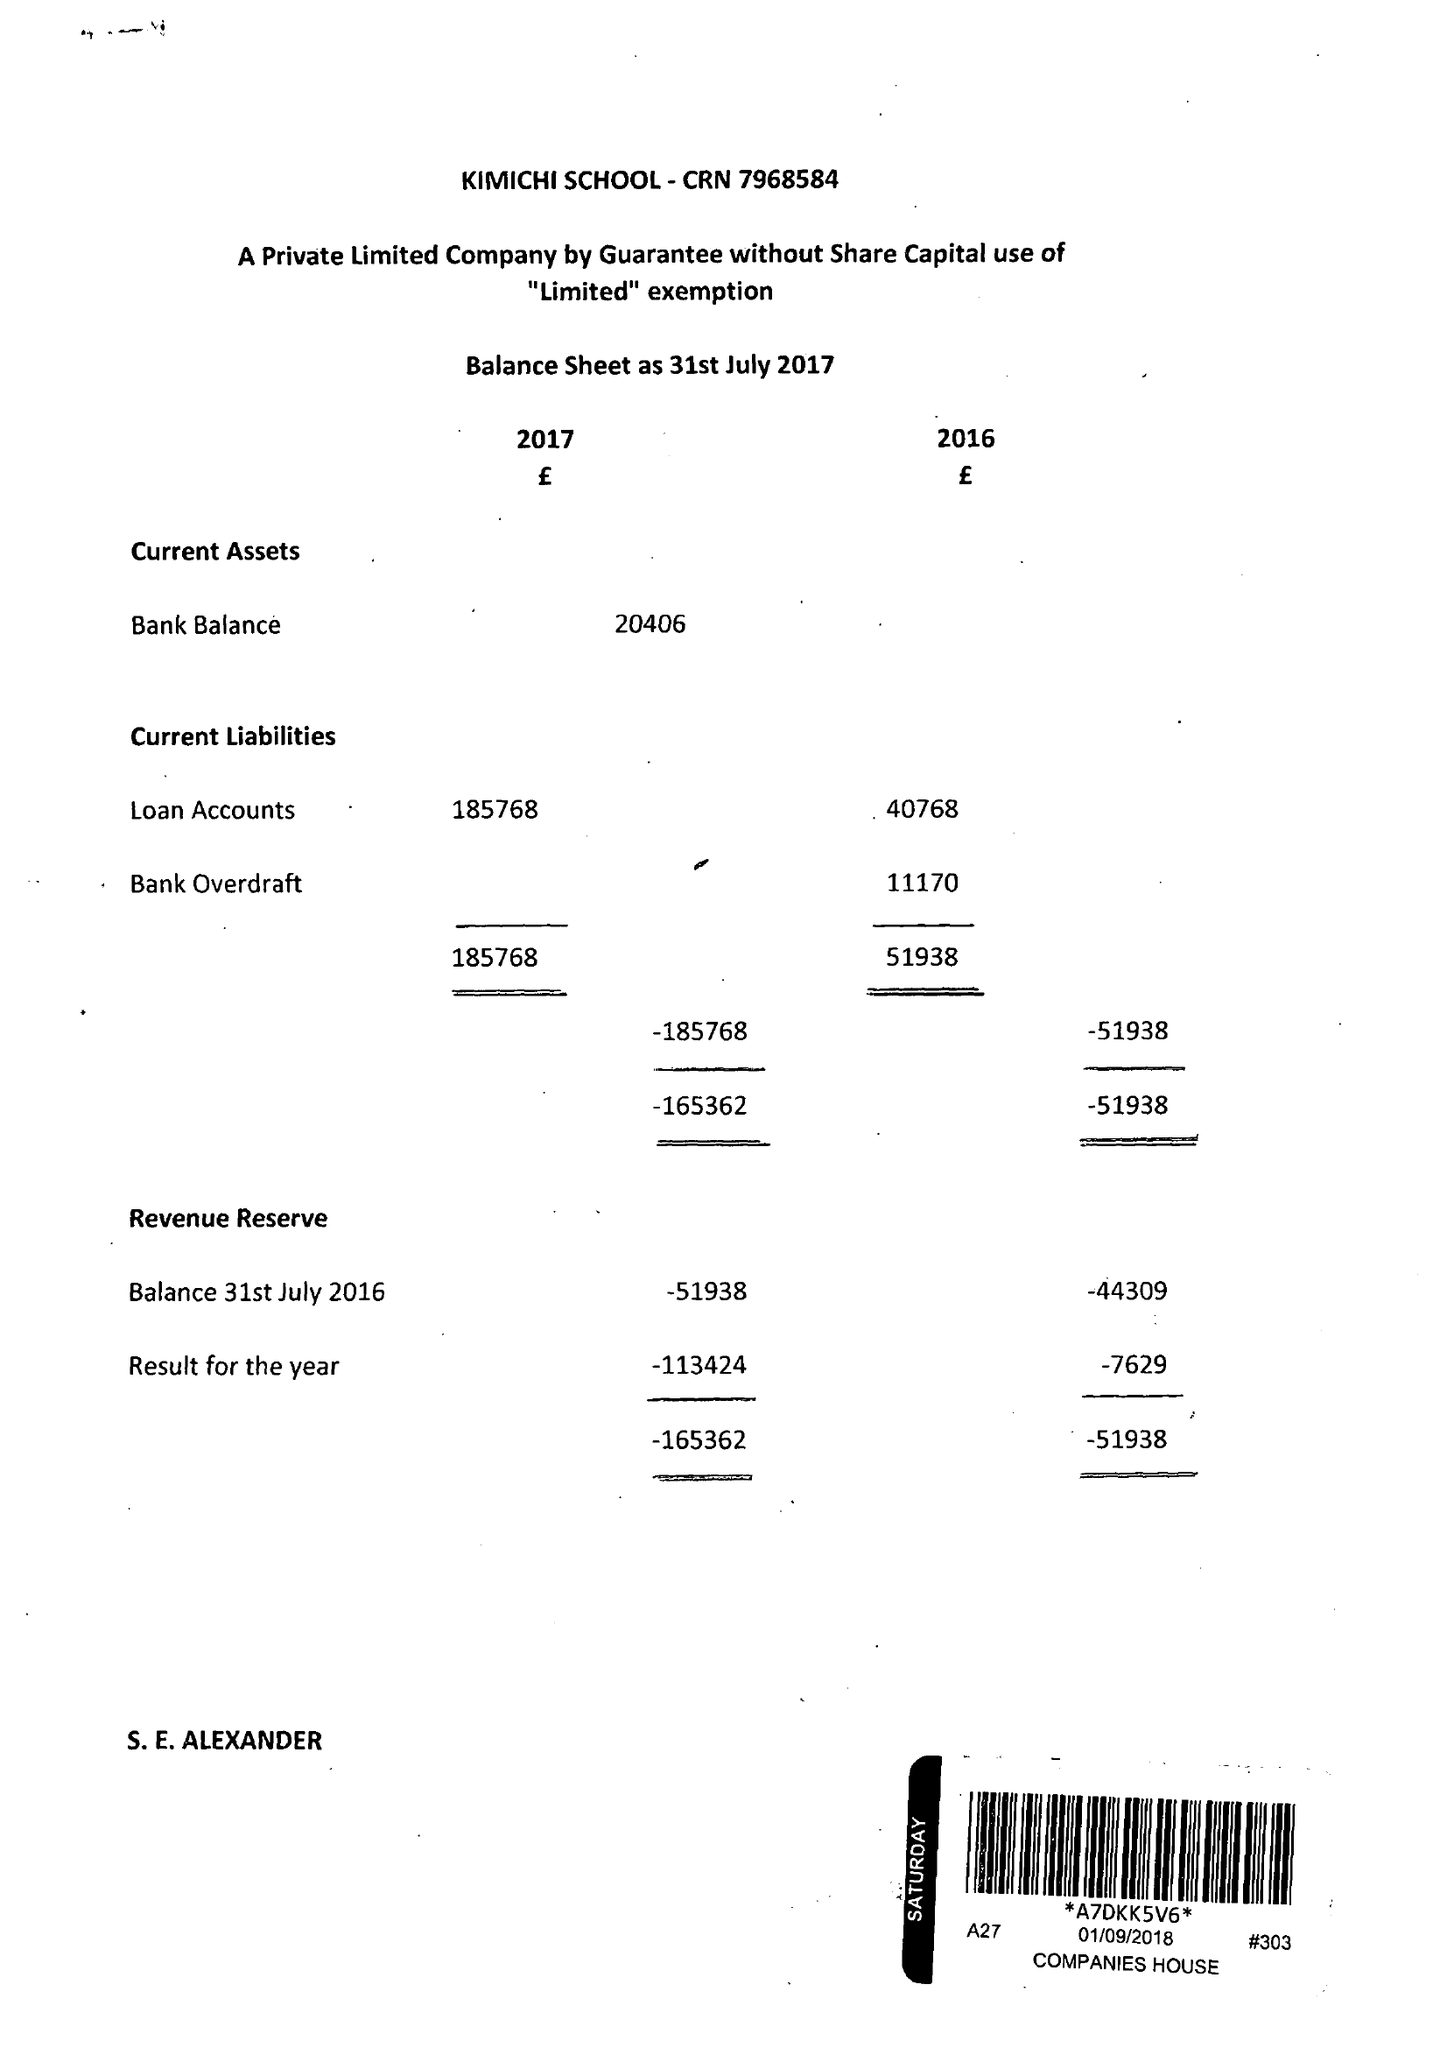What is the value for the report_date?
Answer the question using a single word or phrase. 2017-07-31 